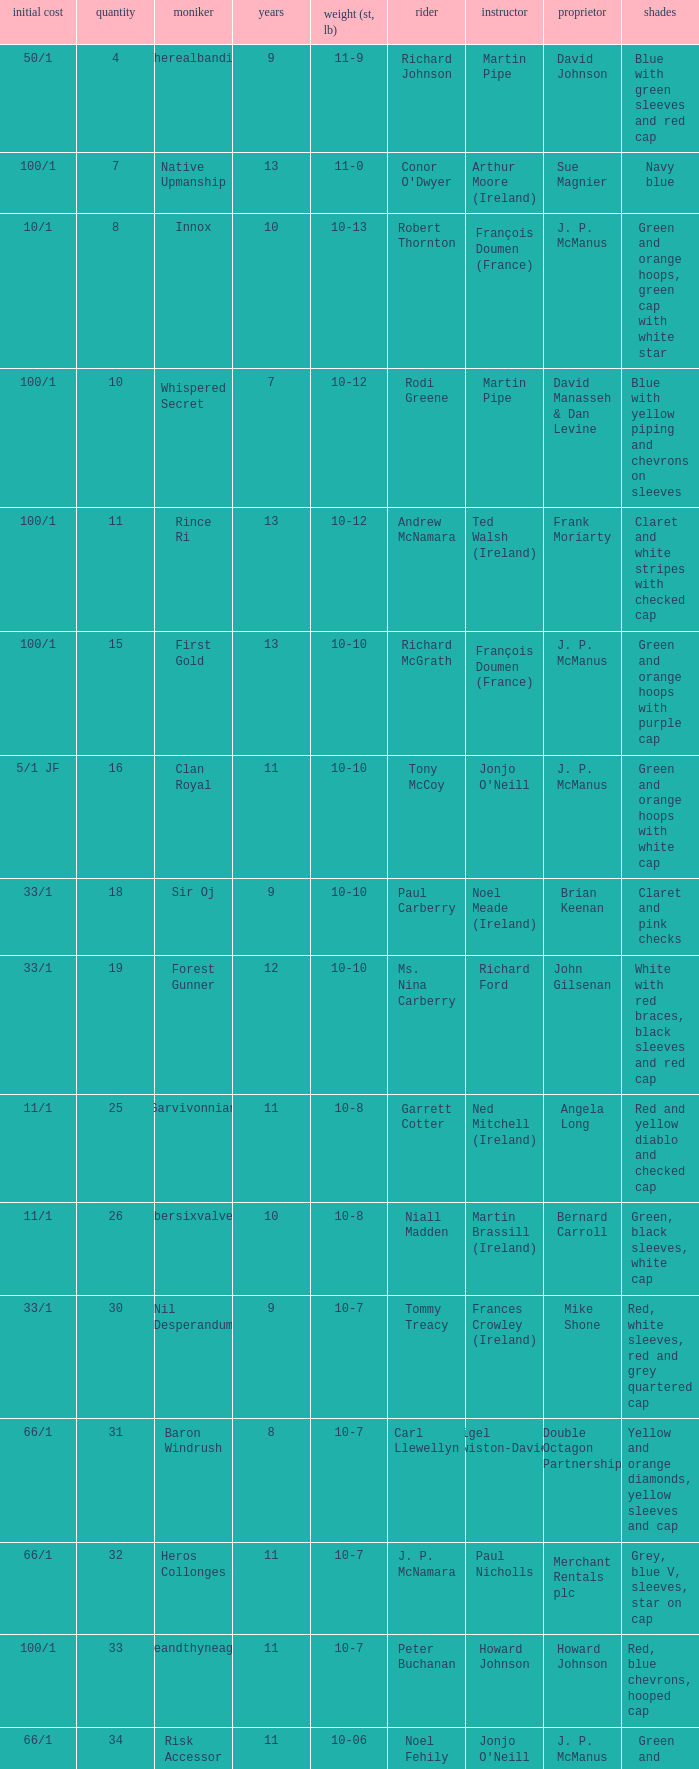What was the name of the entrant with an owner named David Johnson? Therealbandit. 